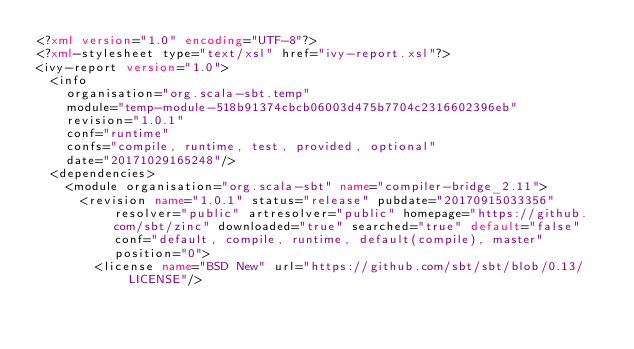Convert code to text. <code><loc_0><loc_0><loc_500><loc_500><_XML_><?xml version="1.0" encoding="UTF-8"?>
<?xml-stylesheet type="text/xsl" href="ivy-report.xsl"?>
<ivy-report version="1.0">
	<info
		organisation="org.scala-sbt.temp"
		module="temp-module-518b91374cbcb06003d475b7704c2316602396eb"
		revision="1.0.1"
		conf="runtime"
		confs="compile, runtime, test, provided, optional"
		date="20171029165248"/>
	<dependencies>
		<module organisation="org.scala-sbt" name="compiler-bridge_2.11">
			<revision name="1.0.1" status="release" pubdate="20170915033356" resolver="public" artresolver="public" homepage="https://github.com/sbt/zinc" downloaded="true" searched="true" default="false" conf="default, compile, runtime, default(compile), master" position="0">
				<license name="BSD New" url="https://github.com/sbt/sbt/blob/0.13/LICENSE"/></code> 